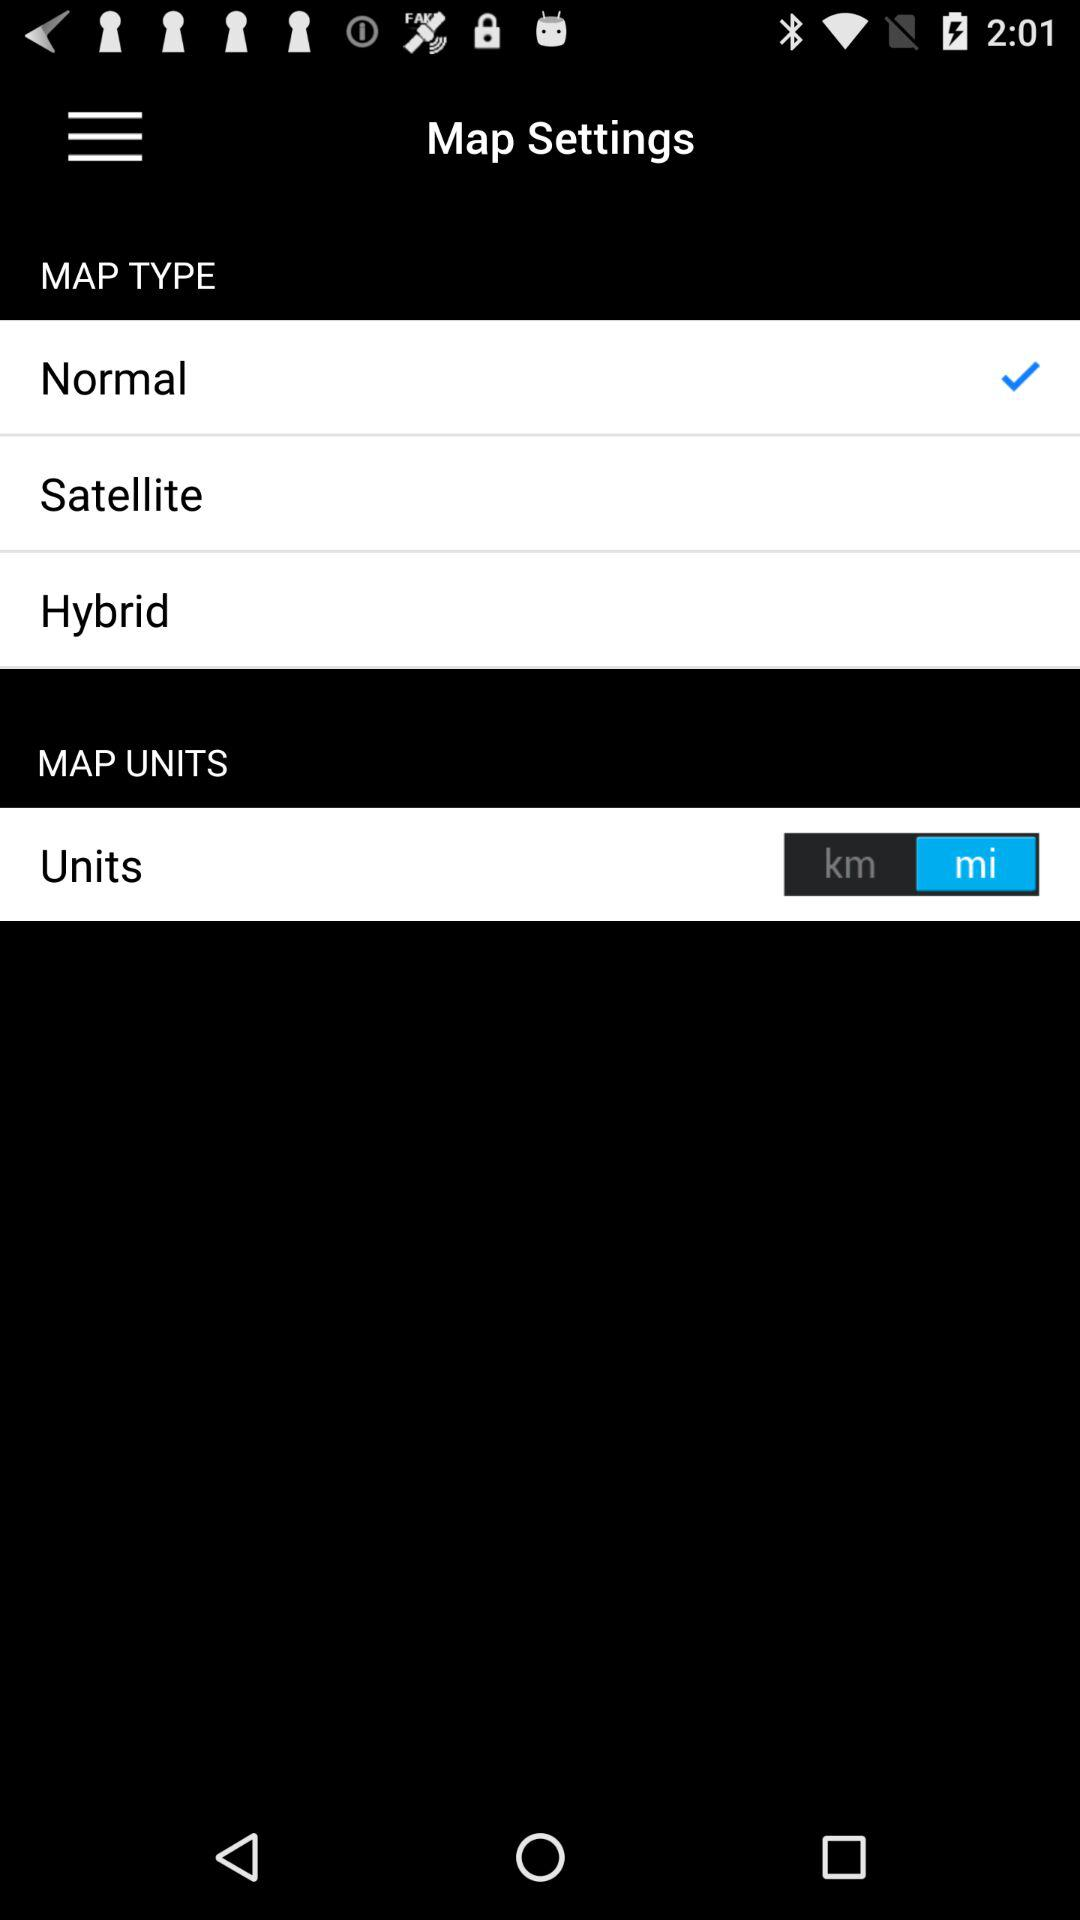What are the selected "MAP UNITS"? The selected "MAP UNITS" is "mi". 